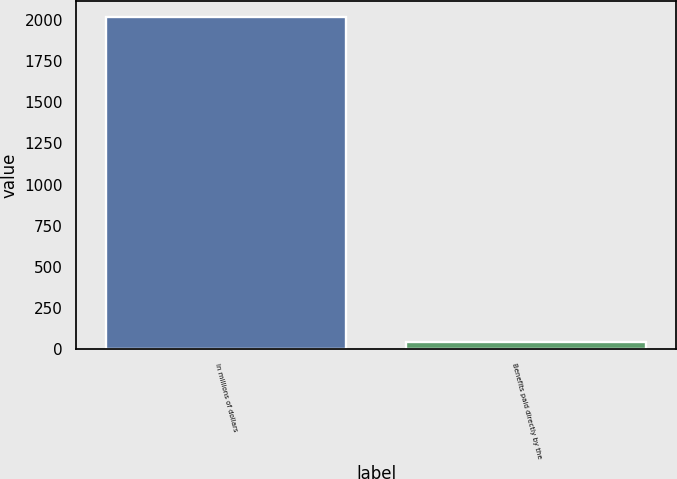<chart> <loc_0><loc_0><loc_500><loc_500><bar_chart><fcel>In millions of dollars<fcel>Benefits paid directly by the<nl><fcel>2017<fcel>45<nl></chart> 